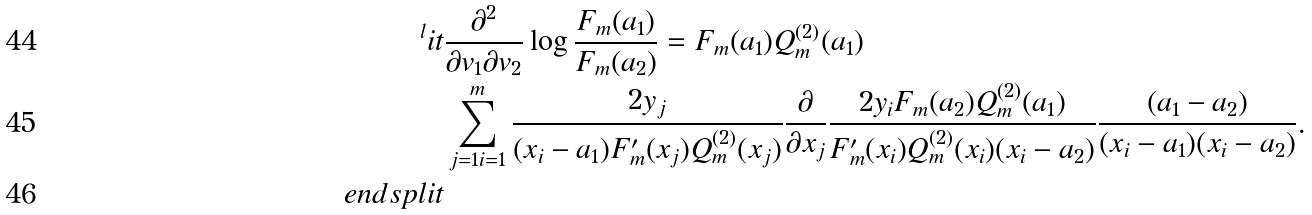Convert formula to latex. <formula><loc_0><loc_0><loc_500><loc_500>^ { l } i t & \frac { \partial ^ { 2 } } { \partial v _ { 1 } \partial v _ { 2 } } \log \frac { F _ { m } ( a _ { 1 } ) } { F _ { m } ( a _ { 2 } ) } = F _ { m } ( a _ { 1 } ) Q ^ { ( 2 ) } _ { m } ( a _ { 1 } ) \\ & \sum _ { j = 1 i = 1 } ^ { m } \frac { 2 y _ { j } } { ( x _ { i } - a _ { 1 } ) F _ { m } ^ { \prime } ( x _ { j } ) Q ^ { ( 2 ) } _ { m } ( x _ { j } ) } \frac { \partial } { \partial x _ { j } } \frac { 2 y _ { i } F _ { m } ( a _ { 2 } ) Q ^ { ( 2 ) } _ { m } ( a _ { 1 } ) } { F _ { m } ^ { \prime } ( x _ { i } ) Q ^ { ( 2 ) } _ { m } ( x _ { i } ) ( x _ { i } - a _ { 2 } ) } \frac { ( a _ { 1 } - a _ { 2 } ) } { ( x _ { i } - a _ { 1 } ) ( x _ { i } - a _ { 2 } ) } . \\ \ e n d s p l i t</formula> 